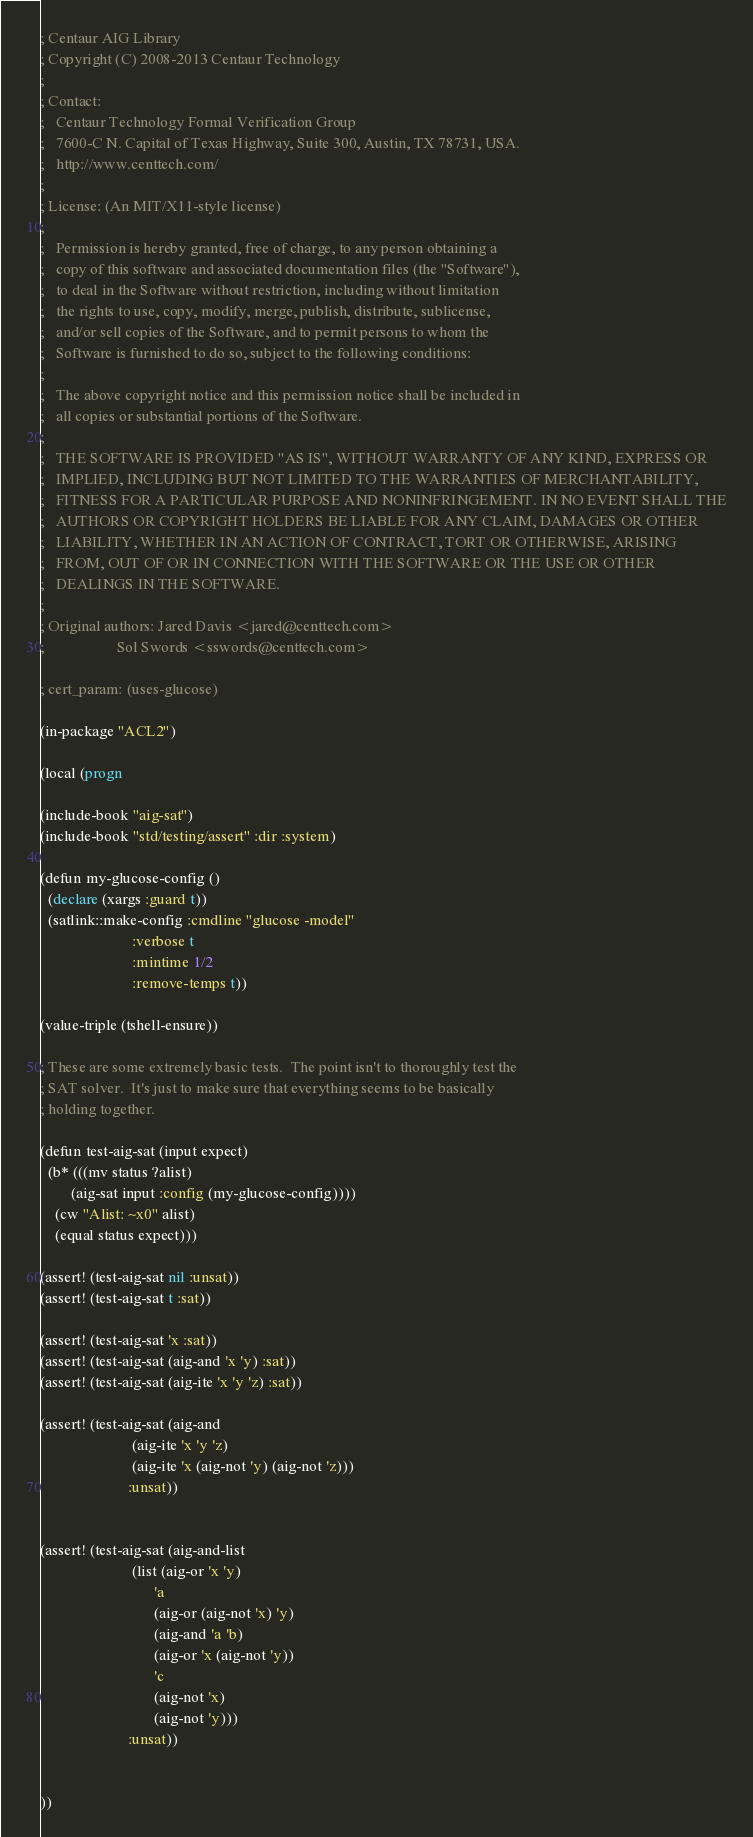<code> <loc_0><loc_0><loc_500><loc_500><_Lisp_>; Centaur AIG Library
; Copyright (C) 2008-2013 Centaur Technology
;
; Contact:
;   Centaur Technology Formal Verification Group
;   7600-C N. Capital of Texas Highway, Suite 300, Austin, TX 78731, USA.
;   http://www.centtech.com/
;
; License: (An MIT/X11-style license)
;
;   Permission is hereby granted, free of charge, to any person obtaining a
;   copy of this software and associated documentation files (the "Software"),
;   to deal in the Software without restriction, including without limitation
;   the rights to use, copy, modify, merge, publish, distribute, sublicense,
;   and/or sell copies of the Software, and to permit persons to whom the
;   Software is furnished to do so, subject to the following conditions:
;
;   The above copyright notice and this permission notice shall be included in
;   all copies or substantial portions of the Software.
;
;   THE SOFTWARE IS PROVIDED "AS IS", WITHOUT WARRANTY OF ANY KIND, EXPRESS OR
;   IMPLIED, INCLUDING BUT NOT LIMITED TO THE WARRANTIES OF MERCHANTABILITY,
;   FITNESS FOR A PARTICULAR PURPOSE AND NONINFRINGEMENT. IN NO EVENT SHALL THE
;   AUTHORS OR COPYRIGHT HOLDERS BE LIABLE FOR ANY CLAIM, DAMAGES OR OTHER
;   LIABILITY, WHETHER IN AN ACTION OF CONTRACT, TORT OR OTHERWISE, ARISING
;   FROM, OUT OF OR IN CONNECTION WITH THE SOFTWARE OR THE USE OR OTHER
;   DEALINGS IN THE SOFTWARE.
;
; Original authors: Jared Davis <jared@centtech.com>
;                   Sol Swords <sswords@centtech.com>

; cert_param: (uses-glucose)

(in-package "ACL2")

(local (progn

(include-book "aig-sat")
(include-book "std/testing/assert" :dir :system)

(defun my-glucose-config ()
  (declare (xargs :guard t))
  (satlink::make-config :cmdline "glucose -model"
                        :verbose t
                        :mintime 1/2
                        :remove-temps t))

(value-triple (tshell-ensure))

; These are some extremely basic tests.  The point isn't to thoroughly test the
; SAT solver.  It's just to make sure that everything seems to be basically
; holding together.

(defun test-aig-sat (input expect)
  (b* (((mv status ?alist)
        (aig-sat input :config (my-glucose-config))))
    (cw "Alist: ~x0" alist)
    (equal status expect)))

(assert! (test-aig-sat nil :unsat))
(assert! (test-aig-sat t :sat))

(assert! (test-aig-sat 'x :sat))
(assert! (test-aig-sat (aig-and 'x 'y) :sat))
(assert! (test-aig-sat (aig-ite 'x 'y 'z) :sat))

(assert! (test-aig-sat (aig-and
                        (aig-ite 'x 'y 'z)
                        (aig-ite 'x (aig-not 'y) (aig-not 'z)))
                       :unsat))


(assert! (test-aig-sat (aig-and-list
                        (list (aig-or 'x 'y)
                              'a
                              (aig-or (aig-not 'x) 'y)
                              (aig-and 'a 'b)
                              (aig-or 'x (aig-not 'y))
                              'c
                              (aig-not 'x)
                              (aig-not 'y)))
                       :unsat))


))
</code> 